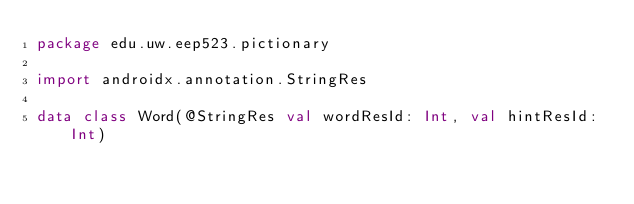Convert code to text. <code><loc_0><loc_0><loc_500><loc_500><_Kotlin_>package edu.uw.eep523.pictionary

import androidx.annotation.StringRes

data class Word(@StringRes val wordResId: Int, val hintResId: Int)</code> 